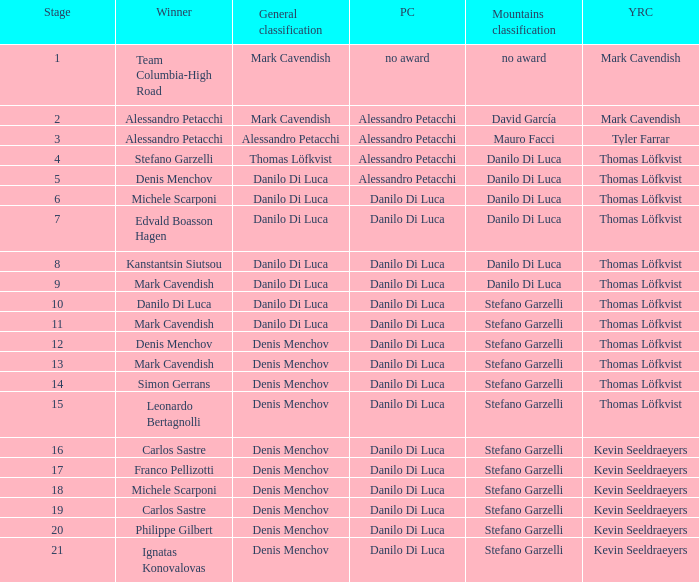When  thomas löfkvist is the general classification who is the winner? Stefano Garzelli. 